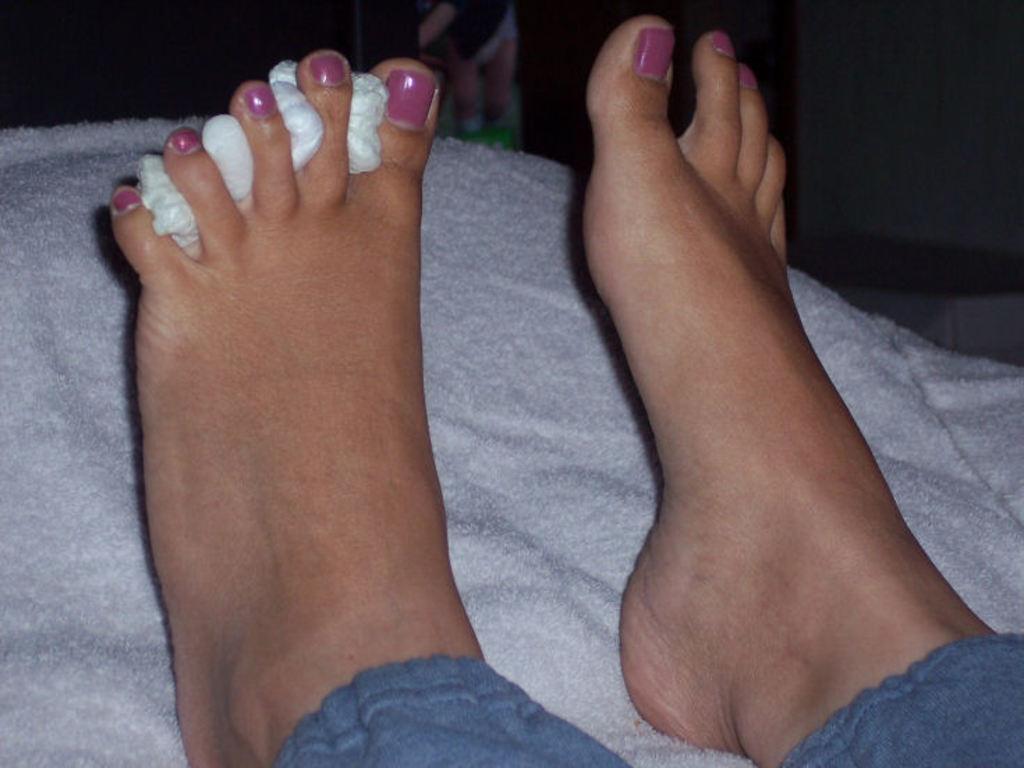Could you give a brief overview of what you see in this image? In this image I can see a person's legs on white color clothes. The background of the image is dark. 